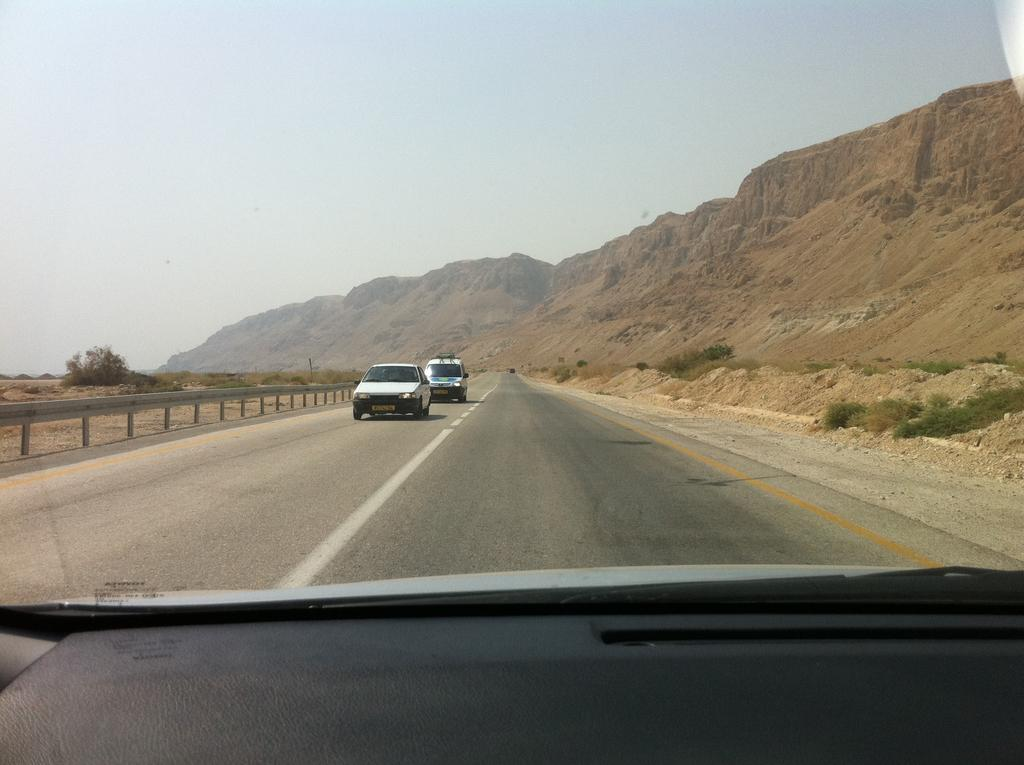What type of setting is depicted in the image? The image is an inside view of a car. What can be seen outside the car in the background? There are two cars visible on the road and trees, hills, and the sky in the background. What type of advertisement can be seen on the trees in the image? There are no advertisements visible on the trees in the image; only trees, hills, and the sky can be seen in the background. 